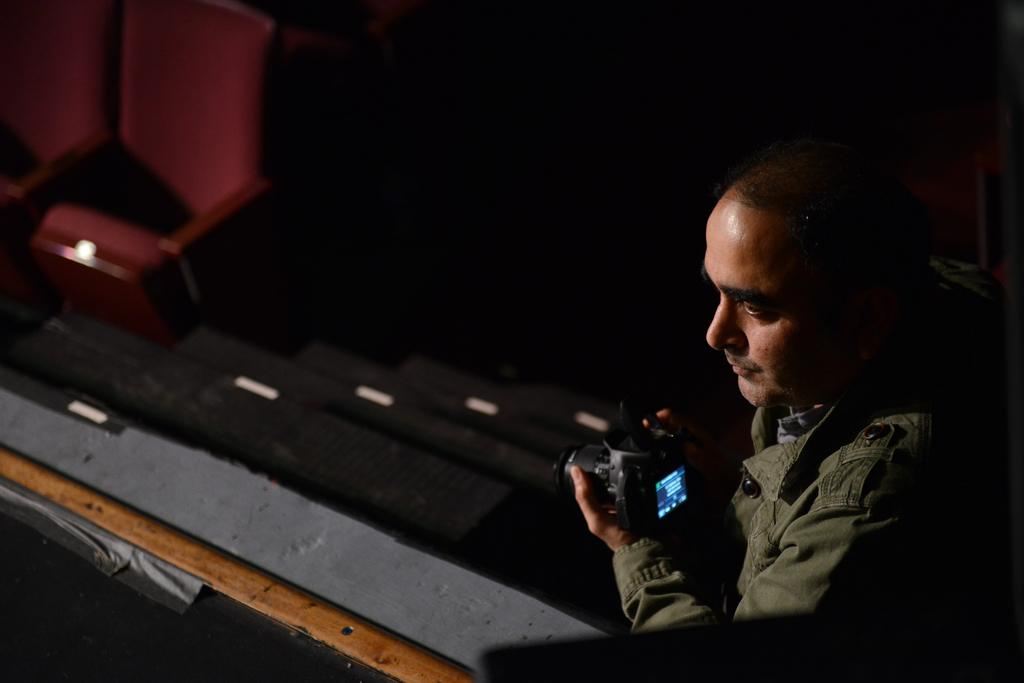What is the person on the right side of the image holding? The person is holding a camera. What can be seen in the top left corner of the image? There are chairs visible in the top left corner of the image. What type of jeans is the person wearing in the image? There is no information about the person's clothing in the image, so we cannot determine if they are wearing jeans or any other type of clothing. 